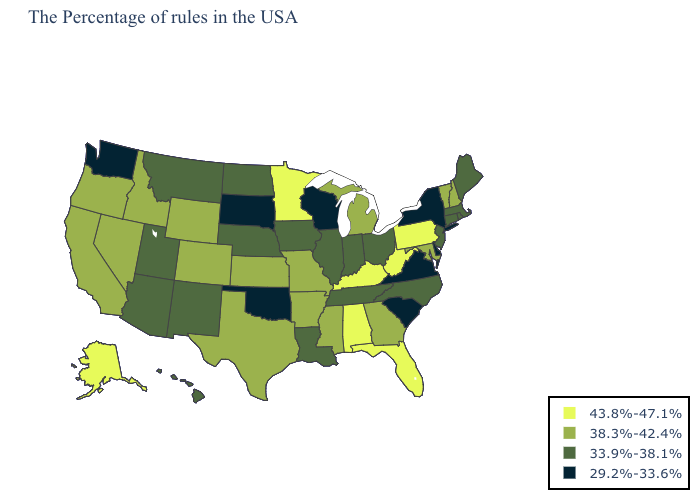What is the value of California?
Keep it brief. 38.3%-42.4%. What is the highest value in states that border Oregon?
Keep it brief. 38.3%-42.4%. Name the states that have a value in the range 43.8%-47.1%?
Give a very brief answer. Pennsylvania, West Virginia, Florida, Kentucky, Alabama, Minnesota, Alaska. What is the value of Tennessee?
Keep it brief. 33.9%-38.1%. Does North Dakota have the lowest value in the MidWest?
Write a very short answer. No. Which states have the lowest value in the Northeast?
Be succinct. New York. Which states have the lowest value in the USA?
Give a very brief answer. New York, Delaware, Virginia, South Carolina, Wisconsin, Oklahoma, South Dakota, Washington. What is the value of Vermont?
Concise answer only. 38.3%-42.4%. Among the states that border Delaware , does New Jersey have the lowest value?
Answer briefly. Yes. What is the lowest value in the West?
Answer briefly. 29.2%-33.6%. What is the highest value in the USA?
Write a very short answer. 43.8%-47.1%. What is the lowest value in the USA?
Answer briefly. 29.2%-33.6%. Name the states that have a value in the range 33.9%-38.1%?
Short answer required. Maine, Massachusetts, Rhode Island, Connecticut, New Jersey, North Carolina, Ohio, Indiana, Tennessee, Illinois, Louisiana, Iowa, Nebraska, North Dakota, New Mexico, Utah, Montana, Arizona, Hawaii. What is the lowest value in states that border New York?
Be succinct. 33.9%-38.1%. Is the legend a continuous bar?
Short answer required. No. 